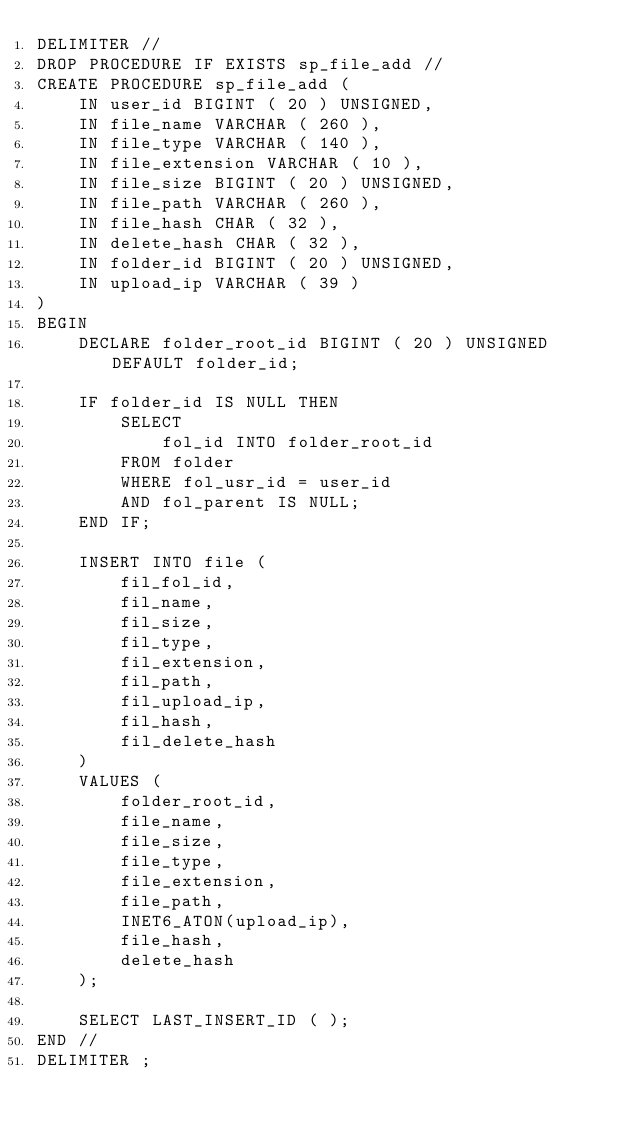<code> <loc_0><loc_0><loc_500><loc_500><_SQL_>DELIMITER //
DROP PROCEDURE IF EXISTS sp_file_add //
CREATE PROCEDURE sp_file_add (
    IN user_id BIGINT ( 20 ) UNSIGNED,
    IN file_name VARCHAR ( 260 ),
    IN file_type VARCHAR ( 140 ),
    IN file_extension VARCHAR ( 10 ),
    IN file_size BIGINT ( 20 ) UNSIGNED,
    IN file_path VARCHAR ( 260 ),
    IN file_hash CHAR ( 32 ),
    IN delete_hash CHAR ( 32 ),
    IN folder_id BIGINT ( 20 ) UNSIGNED,
    IN upload_ip VARCHAR ( 39 )
)
BEGIN
    DECLARE folder_root_id BIGINT ( 20 ) UNSIGNED DEFAULT folder_id;

    IF folder_id IS NULL THEN
		SELECT
		 	fol_id INTO folder_root_id
    	FROM folder
    	WHERE fol_usr_id = user_id
    	AND fol_parent IS NULL;
	END IF;

    INSERT INTO file (
        fil_fol_id,
        fil_name,
        fil_size,
        fil_type,
        fil_extension,
        fil_path,
        fil_upload_ip,
        fil_hash,
        fil_delete_hash
    )
    VALUES (
        folder_root_id,
        file_name,
        file_size,
        file_type,
        file_extension,
        file_path,
        INET6_ATON(upload_ip),
        file_hash,
        delete_hash
    );

	SELECT LAST_INSERT_ID ( );
END //
DELIMITER ;
</code> 